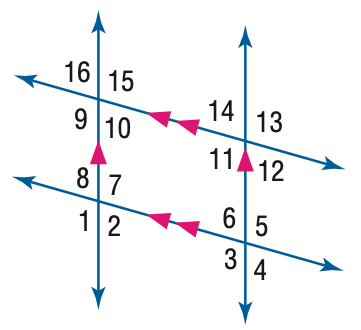Answer the mathemtical geometry problem and directly provide the correct option letter.
Question: In the figure, m \angle 1 = 123. Find the measure of \angle 4.
Choices: A: 47 B: 57 C: 67 D: 123 B 